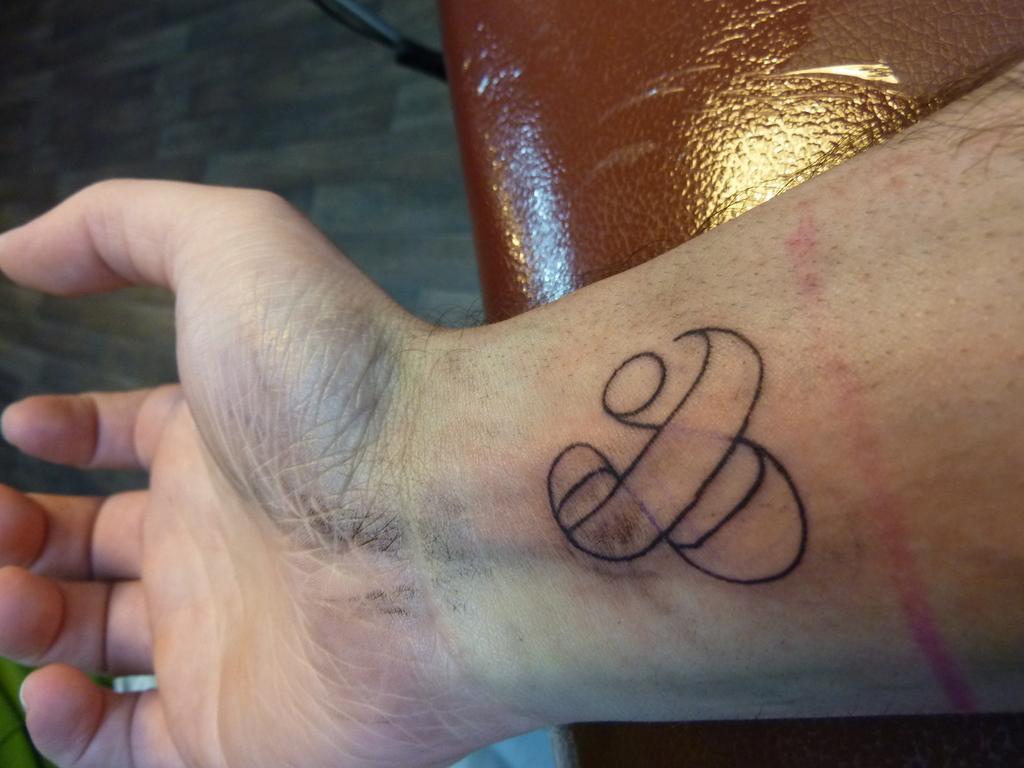How would you summarize this image in a sentence or two? In this image we can see a tattoo on the hand, floor, and an object. 